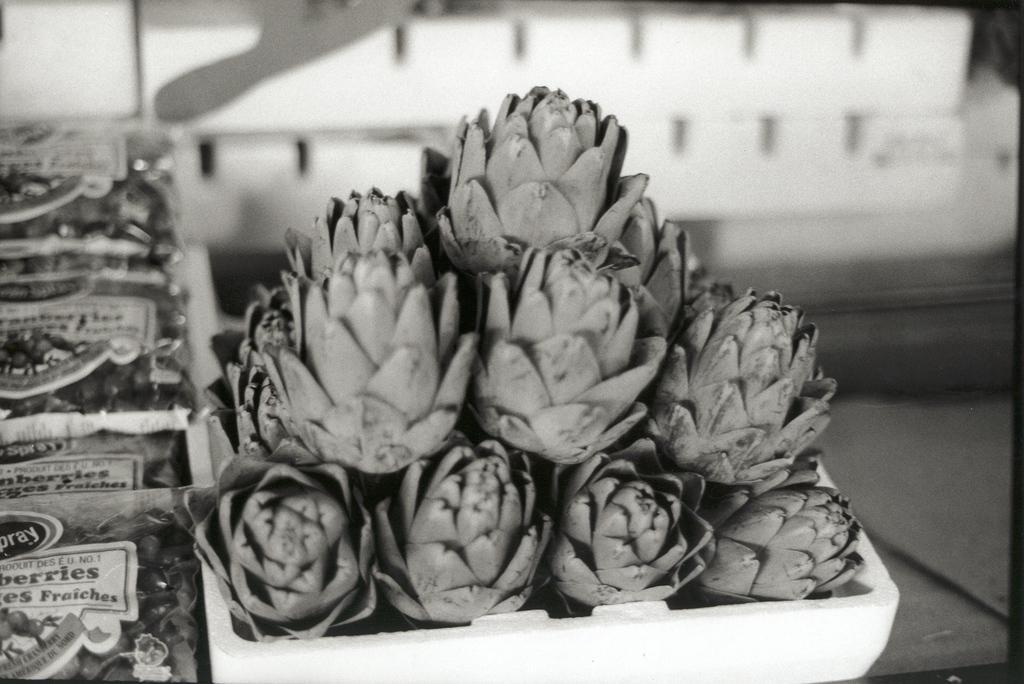Could you give a brief overview of what you see in this image? In this image I can see few flowers in the bowl and I can also see few packets and I can see the blurred background and the image is in black and white. 